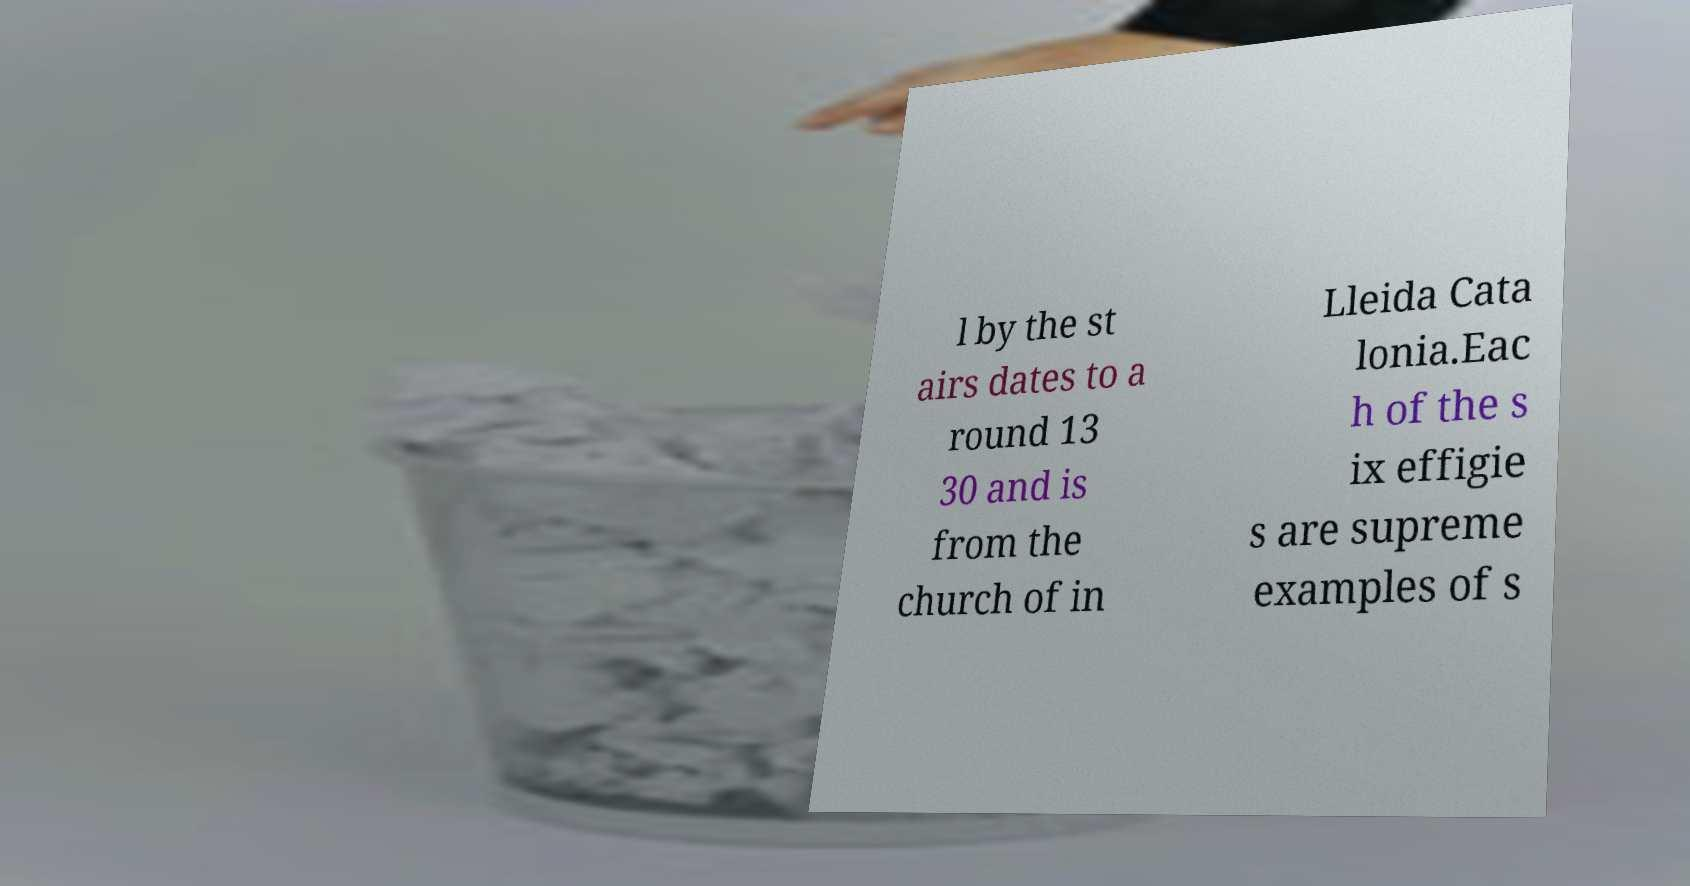I need the written content from this picture converted into text. Can you do that? l by the st airs dates to a round 13 30 and is from the church of in Lleida Cata lonia.Eac h of the s ix effigie s are supreme examples of s 